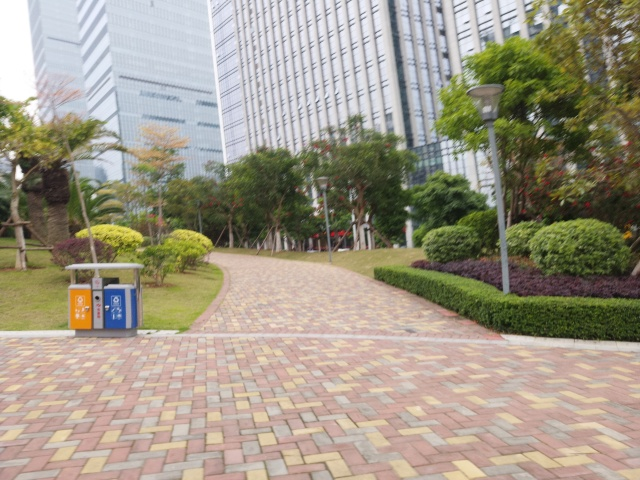Are there any people in the image? From the current perspective, there are no visible people, suggesting that the photo was taken at a time with minimal pedestrian traffic, or possibly that the area is more secluded and less frequently occupied. 